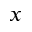<formula> <loc_0><loc_0><loc_500><loc_500>x</formula> 